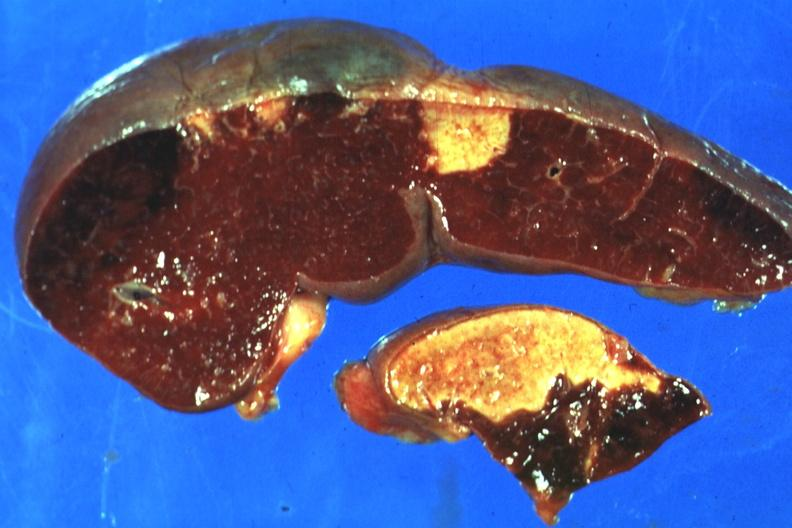how does this image show excellent side?
Answer the question using a single word or phrase. With four infarcts shown which are several days of age from nonbacterial endocarditis 